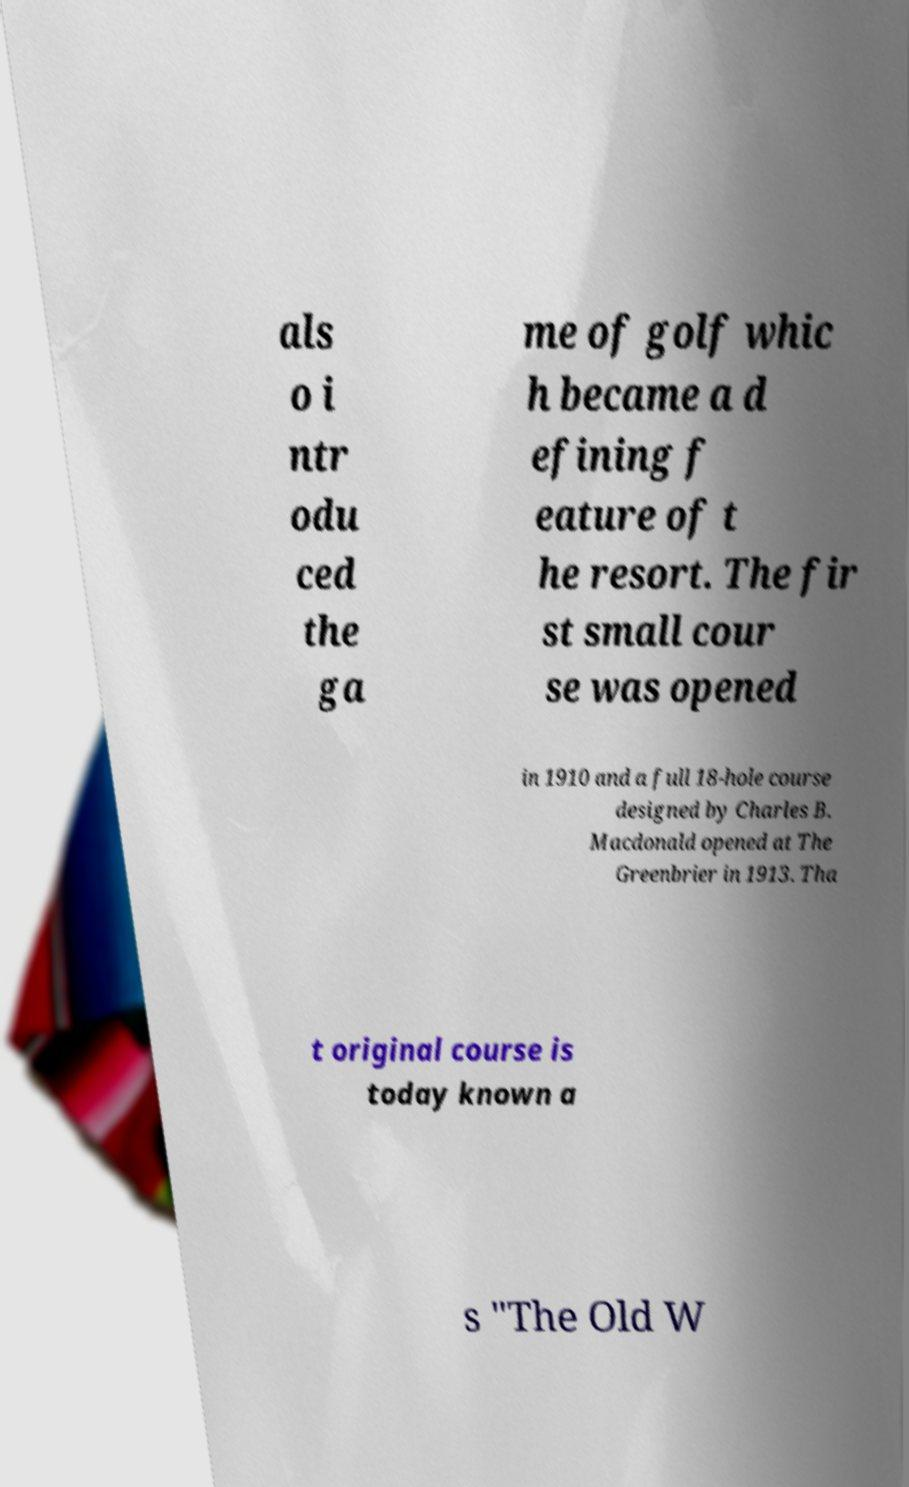Could you assist in decoding the text presented in this image and type it out clearly? als o i ntr odu ced the ga me of golf whic h became a d efining f eature of t he resort. The fir st small cour se was opened in 1910 and a full 18-hole course designed by Charles B. Macdonald opened at The Greenbrier in 1913. Tha t original course is today known a s "The Old W 